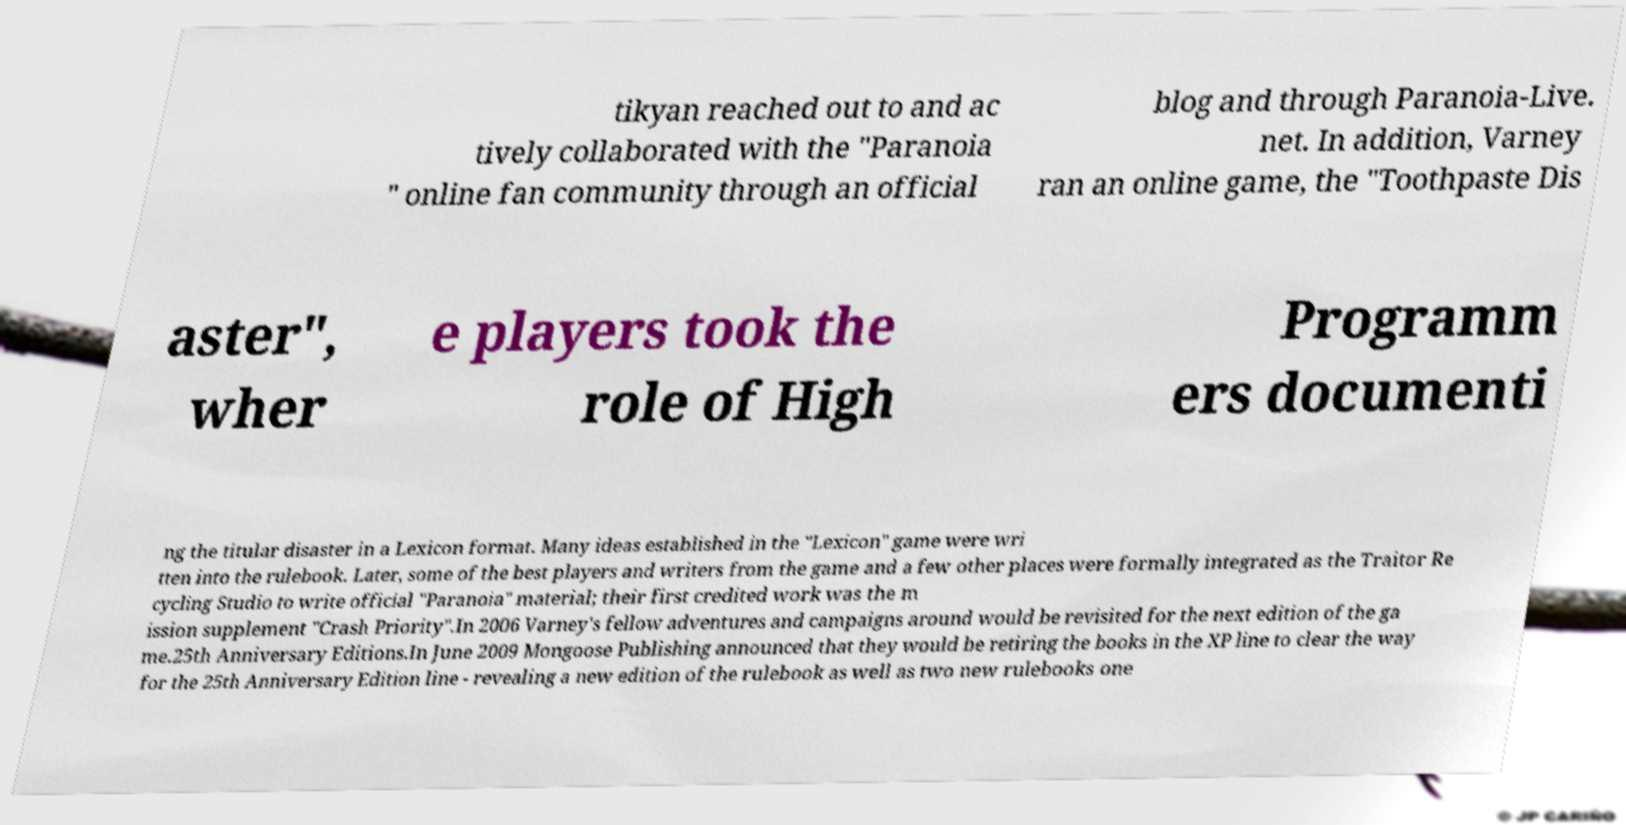There's text embedded in this image that I need extracted. Can you transcribe it verbatim? tikyan reached out to and ac tively collaborated with the "Paranoia " online fan community through an official blog and through Paranoia-Live. net. In addition, Varney ran an online game, the "Toothpaste Dis aster", wher e players took the role of High Programm ers documenti ng the titular disaster in a Lexicon format. Many ideas established in the "Lexicon" game were wri tten into the rulebook. Later, some of the best players and writers from the game and a few other places were formally integrated as the Traitor Re cycling Studio to write official "Paranoia" material; their first credited work was the m ission supplement "Crash Priority".In 2006 Varney's fellow adventures and campaigns around would be revisited for the next edition of the ga me.25th Anniversary Editions.In June 2009 Mongoose Publishing announced that they would be retiring the books in the XP line to clear the way for the 25th Anniversary Edition line - revealing a new edition of the rulebook as well as two new rulebooks one 